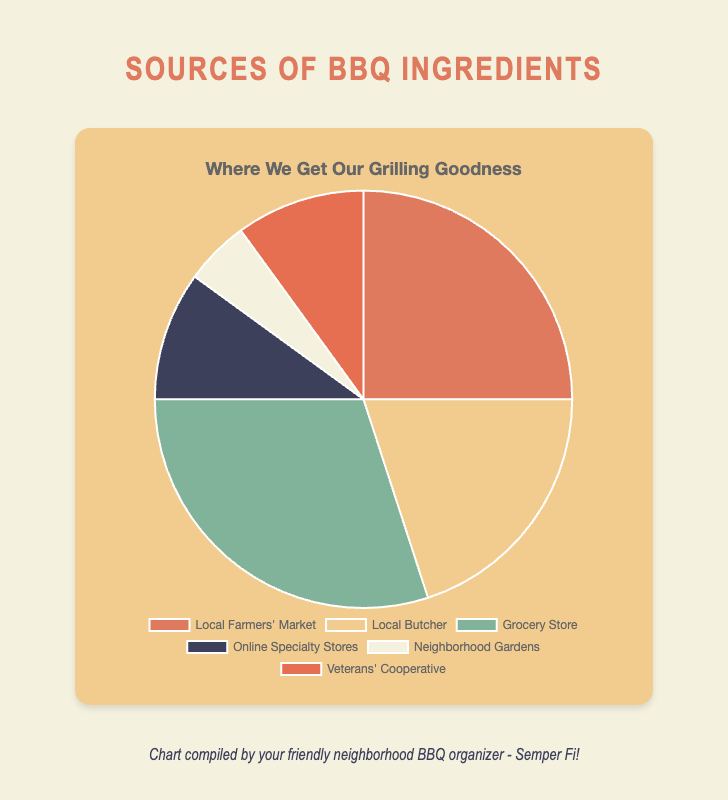what is the most common source of ingredients for BBQ grills? The source with the highest percentage is 'Grocery Store' at 30%.
Answer: Grocery Store Which source of ingredients supplies the least amount for BBQ grills? The 'Neighborhood Gardens' supplies the least amount, with only 5%.
Answer: Neighborhood Gardens What percentage of ingredients come from online sources combined? Online sources include 'Online Specialty Stores' at 10% and 'Veterans' Cooperative' at 10%. Adding these gives 20%.
Answer: 20% How many sources provide more than 20% of the ingredients for BBQ grills? Only one source provides more than 20%, which is the 'Grocery Store' at 30%.
Answer: One source Compare the percentage of ingredients sourced from the Local Farmers' Market and the Local Butcher. Which is higher and by how much? Local Farmers' Market is at 25% and Local Butcher at 20%. Local Farmers' Market is higher by 5%.
Answer: Local Farmers' Market by 5% Which sections of the pie chart are represented by earth tones (like green and brown)? Earth tones (green and brown) in the chart are represented by 'Local Butcher' and 'Neighborhood Gardens'.
Answer: Local Butcher, Neighborhood Gardens If we combine the percentages from Local Farmers' Market and Local Butcher, what fraction of the total ingredients do they represent? Adding 'Local Farmers' Market' (25%) and 'Local Butcher' (20%) gives 45%. The fraction is 45/100 or 0.45.
Answer: 0.45 What color corresponds to the 'Grocery Store' section of the pie chart? The 'Grocery Store' section is represented by the color green.
Answer: Green If we add the percentage from the sources that provide at least 10% of the ingredients, what total do we get? Adding percentages from 'Local Farmers' Market' (25%), 'Local Butcher' (20%), 'Grocery Store' (30%), 'Online Specialty Stores' (10%), 'Veterans' Cooperative' (10%) gives 95%.
Answer: 95% Is the percentage of ingredients from Veterans' Cooperative more than that from Neighborhood Gardens? Yes, Veterans' Cooperative is at 10%, whereas Neighborhood Gardens is at 5%. So it is more by 5%.
Answer: Yes, more by 5% 